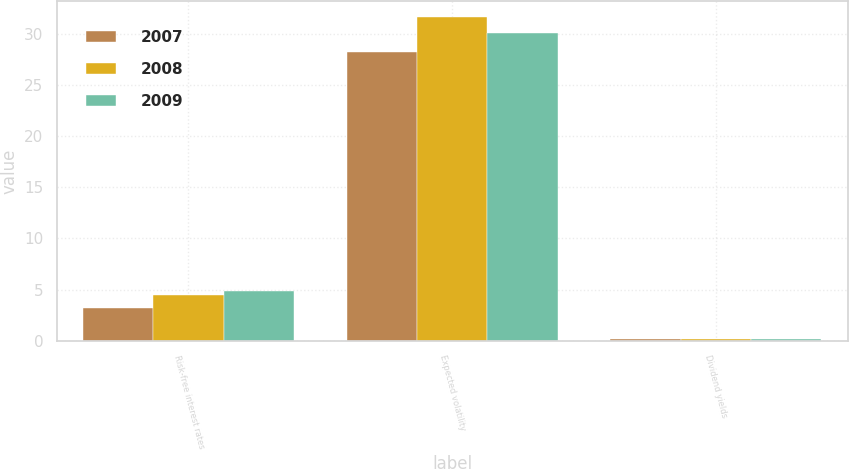<chart> <loc_0><loc_0><loc_500><loc_500><stacked_bar_chart><ecel><fcel>Risk-free interest rates<fcel>Expected volatility<fcel>Dividend yields<nl><fcel>2007<fcel>3.15<fcel>28.27<fcel>0.19<nl><fcel>2008<fcel>4.49<fcel>31.67<fcel>0.19<nl><fcel>2009<fcel>4.85<fcel>30.11<fcel>0.19<nl></chart> 